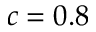<formula> <loc_0><loc_0><loc_500><loc_500>c = 0 . 8</formula> 